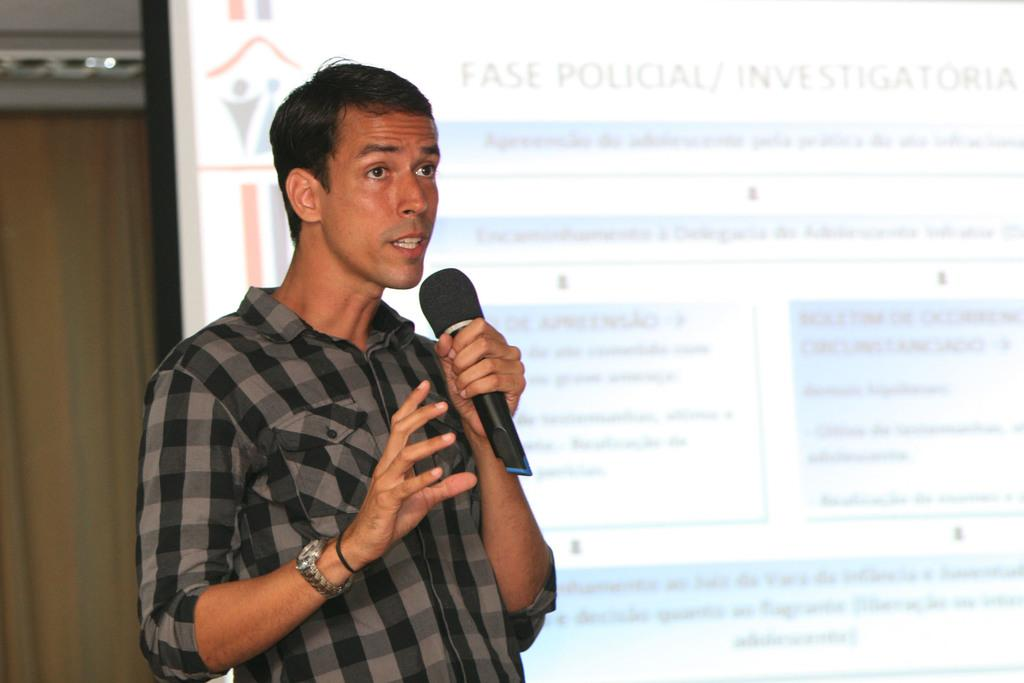What is the main subject of the image? There is a person standing in the image. What is the person wearing? The person is wearing a shirt. What object is the person holding in their left hand? The person is holding a microphone in their left hand. What can be seen in the background of the image? There is a screen in the background of the image. What type of jam is being spread on the glove in the image? There is no jam or glove present in the image. Where is the park located in the image? There is no park present in the image. 